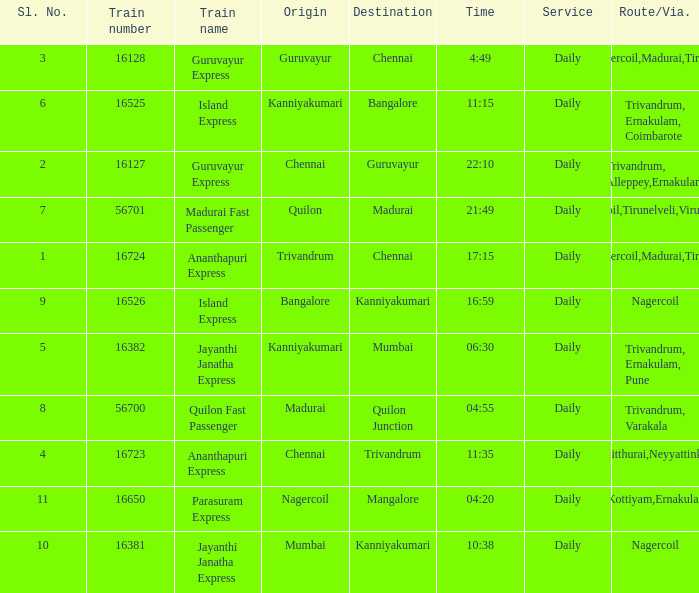Write the full table. {'header': ['Sl. No.', 'Train number', 'Train name', 'Origin', 'Destination', 'Time', 'Service', 'Route/Via.'], 'rows': [['3', '16128', 'Guruvayur Express', 'Guruvayur', 'Chennai', '4:49', 'Daily', 'Nagercoil,Madurai,Tiruchi'], ['6', '16525', 'Island Express', 'Kanniyakumari', 'Bangalore', '11:15', 'Daily', 'Trivandrum, Ernakulam, Coimbarote'], ['2', '16127', 'Guruvayur Express', 'Chennai', 'Guruvayur', '22:10', 'Daily', 'Trivandrum, Alleppey,Ernakulam'], ['7', '56701', 'Madurai Fast Passenger', 'Quilon', 'Madurai', '21:49', 'Daily', 'Nagercoil,Tirunelveli,Virudunagar'], ['1', '16724', 'Ananthapuri Express', 'Trivandrum', 'Chennai', '17:15', 'Daily', 'Nagercoil,Madurai,Tiruchi'], ['9', '16526', 'Island Express', 'Bangalore', 'Kanniyakumari', '16:59', 'Daily', 'Nagercoil'], ['5', '16382', 'Jayanthi Janatha Express', 'Kanniyakumari', 'Mumbai', '06:30', 'Daily', 'Trivandrum, Ernakulam, Pune'], ['8', '56700', 'Quilon Fast Passenger', 'Madurai', 'Quilon Junction', '04:55', 'Daily', 'Trivandrum, Varakala'], ['4', '16723', 'Ananthapuri Express', 'Chennai', 'Trivandrum', '11:35', 'Daily', 'Kulitthurai,Neyyattinkara'], ['11', '16650', 'Parasuram Express', 'Nagercoil', 'Mangalore', '04:20', 'Daily', 'Trivandrum,Kottiyam,Ernakulam,Kozhikode'], ['10', '16381', 'Jayanthi Janatha Express', 'Mumbai', 'Kanniyakumari', '10:38', 'Daily', 'Nagercoil']]} What is the train number when the time is 10:38? 16381.0. 